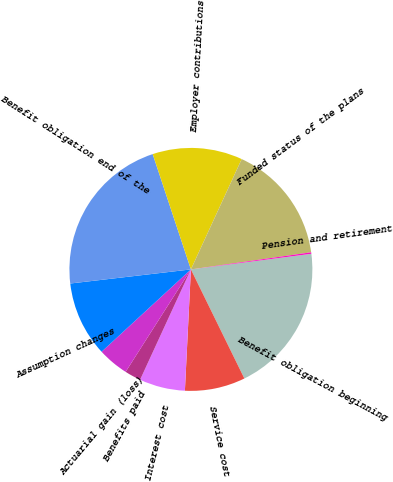<chart> <loc_0><loc_0><loc_500><loc_500><pie_chart><fcel>Benefit obligation beginning<fcel>Service cost<fcel>Interest cost<fcel>Benefits paid<fcel>Actuarial gain (loss)<fcel>Assumption changes<fcel>Benefit obligation end of the<fcel>Employer contributions<fcel>Funded status of the plans<fcel>Pension and retirement<nl><fcel>19.8%<fcel>8.04%<fcel>6.08%<fcel>2.16%<fcel>4.12%<fcel>10.0%<fcel>21.76%<fcel>11.96%<fcel>15.88%<fcel>0.2%<nl></chart> 